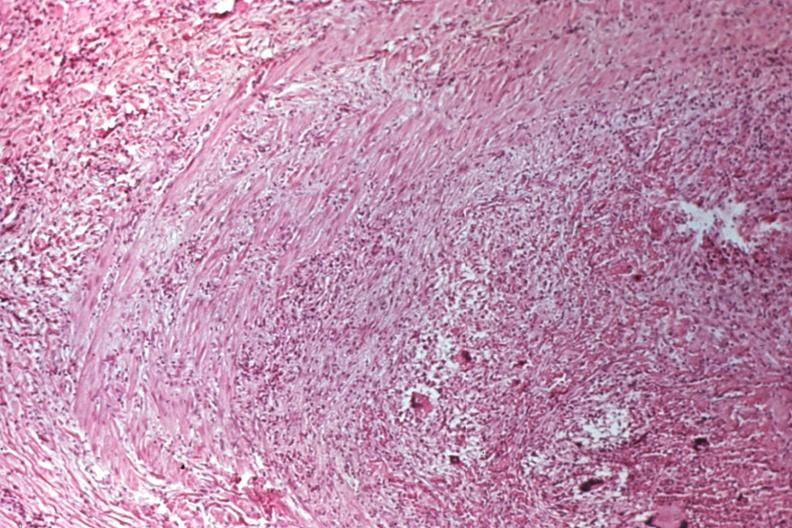does this image show migratory thrombophlebitis?
Answer the question using a single word or phrase. Yes 